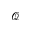<formula> <loc_0><loc_0><loc_500><loc_500>\mathcal { Q }</formula> 